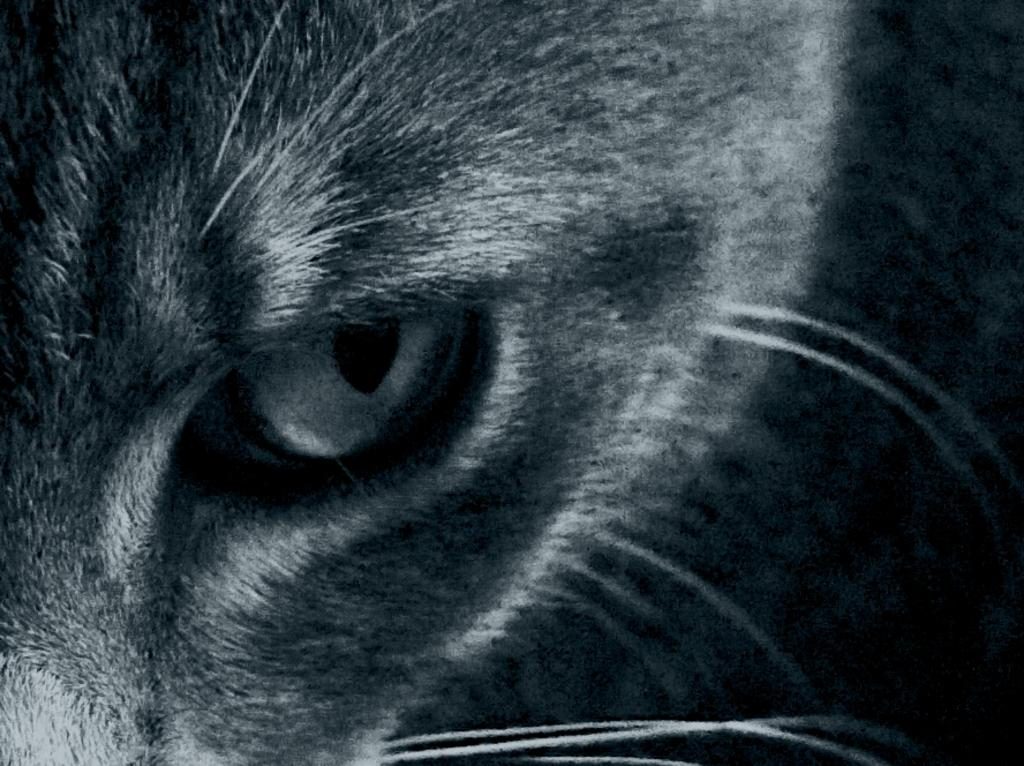What is the main subject of the image? The main subject of the image is the eye of an animal. What type of summer activity is depicted in the image? There is no summer activity depicted in the image, as it only features the eye of an animal. What type of tray is used to serve the food in the image? There is no tray or food present in the image; it only features the eye of an animal. 